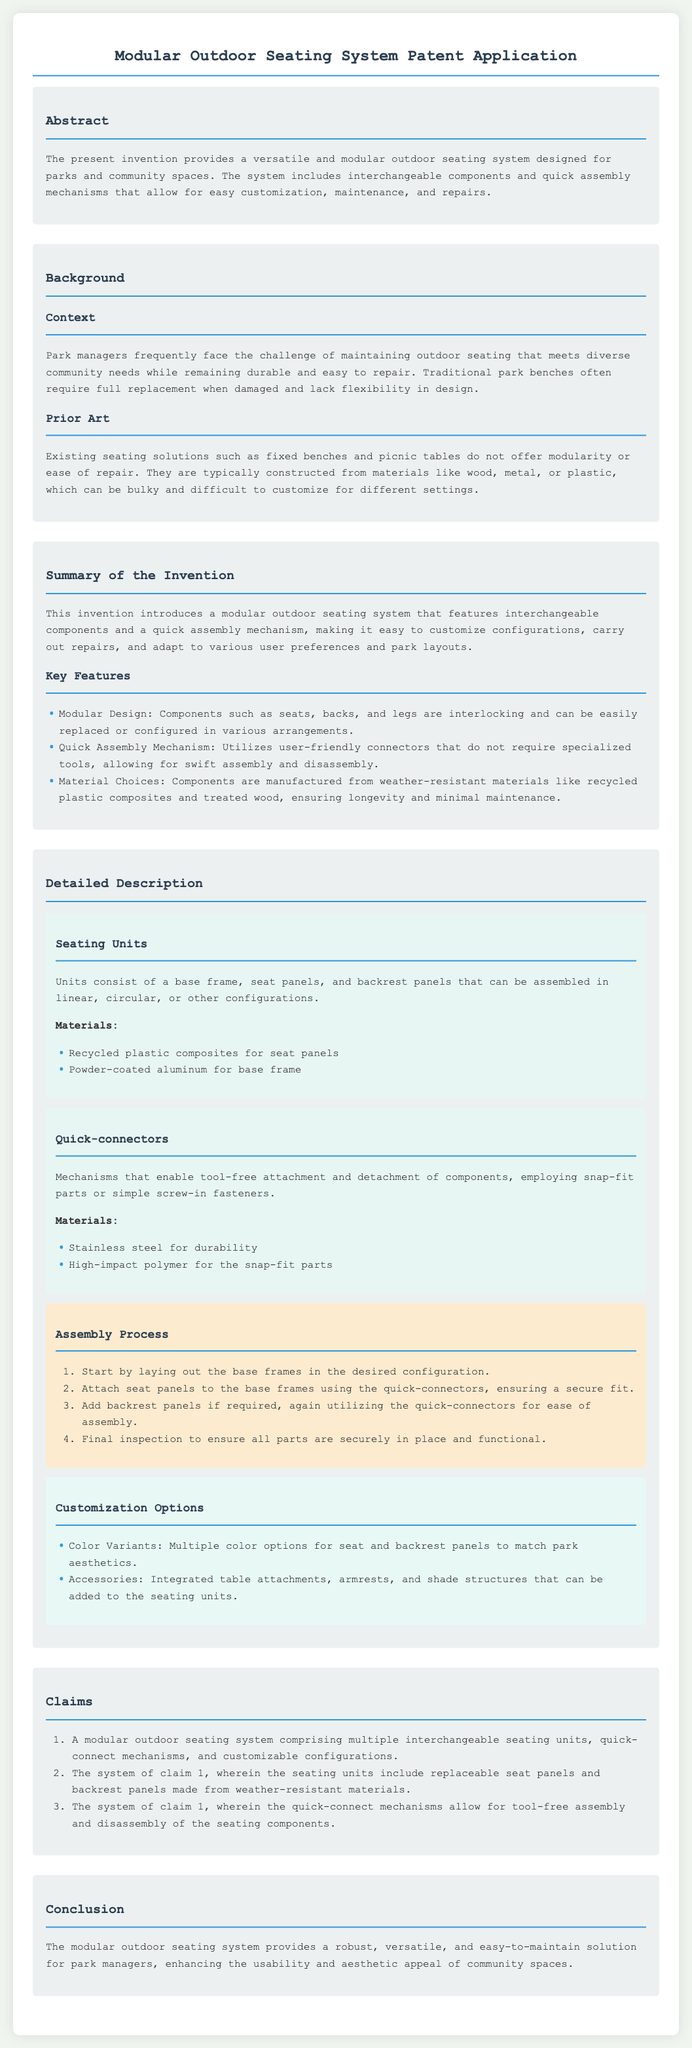What is the title of the patent application? The title of the patent application is stated at the top of the document.
Answer: Modular Outdoor Seating System Patent Application What type of materials are used for the seat panels? The materials for the seat panels are mentioned in the detailed description section.
Answer: Recycled plastic composites What is one key feature of the modular outdoor seating system? A key feature of the system is highlighted in the summary section under ‘Key Features’.
Answer: Modular Design How many claims are made in the document? The number of claims is found in the claims section of the patent application.
Answer: Three What does the assembly process begin with? The assembly process is outlined in a specific order in the detailed description section.
Answer: Laying out the base frames What customization option is offered for the seating units? Customization options are detailed in the description part of the document.
Answer: Color Variants What type of connectors are used in the seating system? The type of connectors is specified in the detailed description section.
Answer: Quick-connectors What is the primary purpose of the modular outdoor seating system? The purpose is summarized in the conclusion of the document.
Answer: Easy-to-maintain solution What is a significant challenge faced by park managers mentioned in the background? This challenge is related to the maintenance of outdoor seating as described in the background section.
Answer: Maintaining outdoor seating 